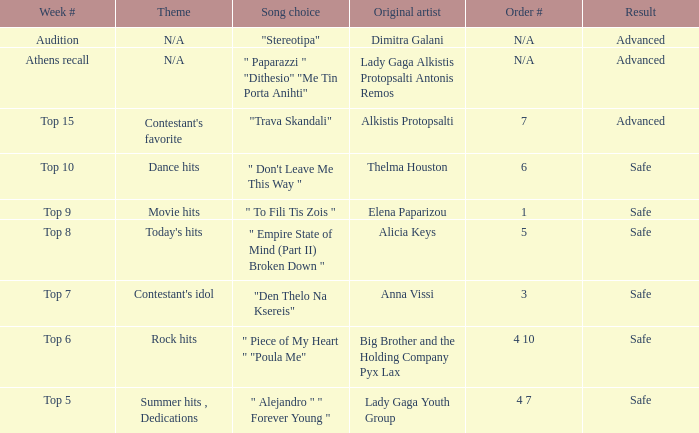Which artists possess order # 1? Elena Paparizou. 